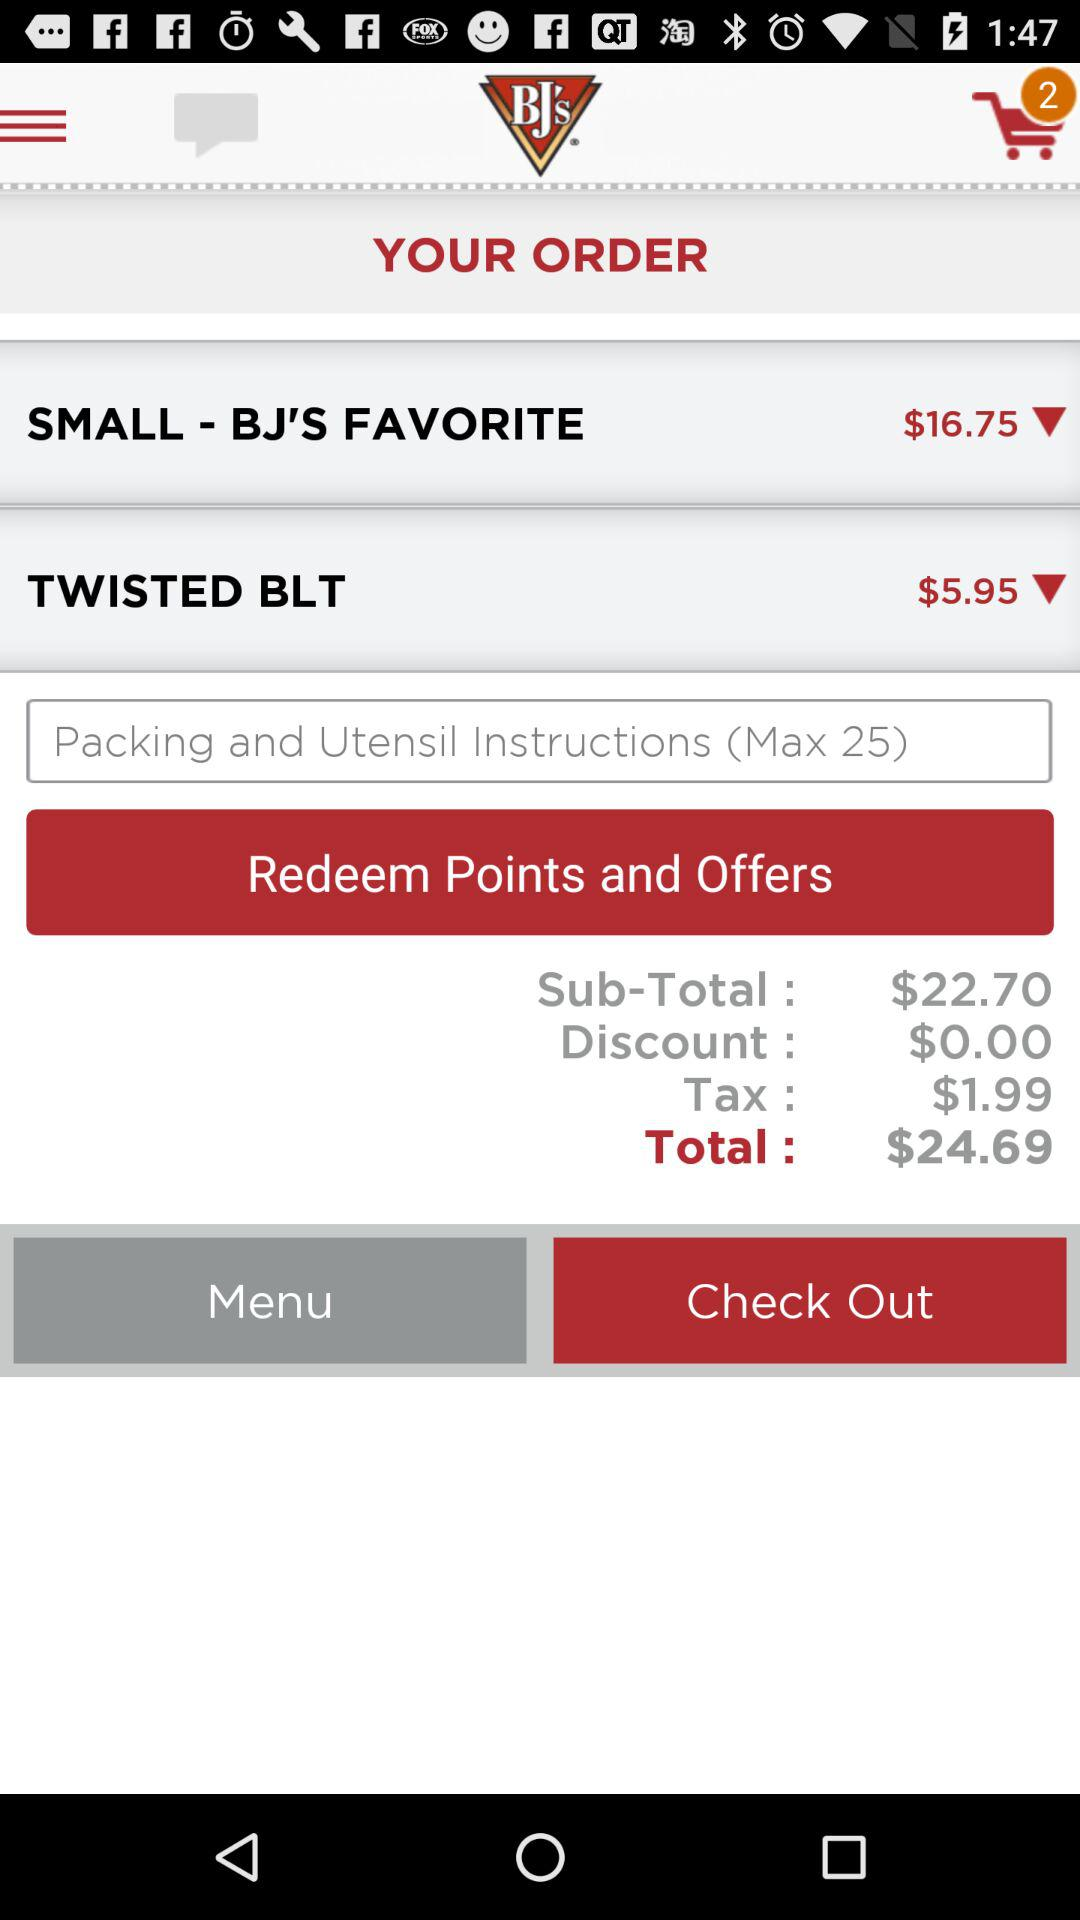What are the packaging and utensil instructions?
When the provided information is insufficient, respond with <no answer>. <no answer> 